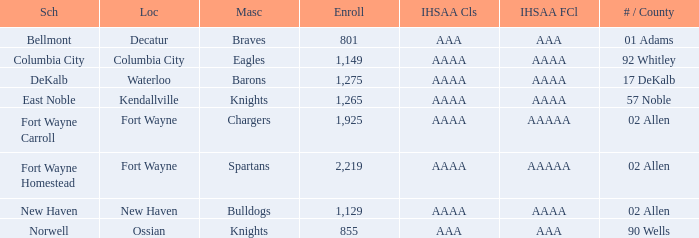What's the IHSAA Football Class in Decatur with an AAA IHSAA class? AAA. 